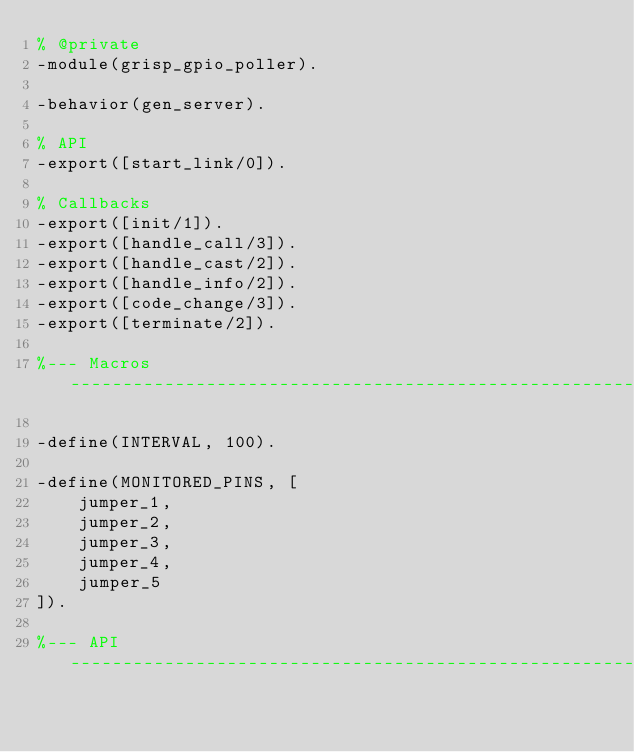Convert code to text. <code><loc_0><loc_0><loc_500><loc_500><_Erlang_>% @private
-module(grisp_gpio_poller).

-behavior(gen_server).

% API
-export([start_link/0]).

% Callbacks
-export([init/1]).
-export([handle_call/3]).
-export([handle_cast/2]).
-export([handle_info/2]).
-export([code_change/3]).
-export([terminate/2]).

%--- Macros --------------------------------------------------------------------

-define(INTERVAL, 100).

-define(MONITORED_PINS, [
    jumper_1,
    jumper_2,
    jumper_3,
    jumper_4,
    jumper_5
]).

%--- API -----------------------------------------------------------------------
</code> 